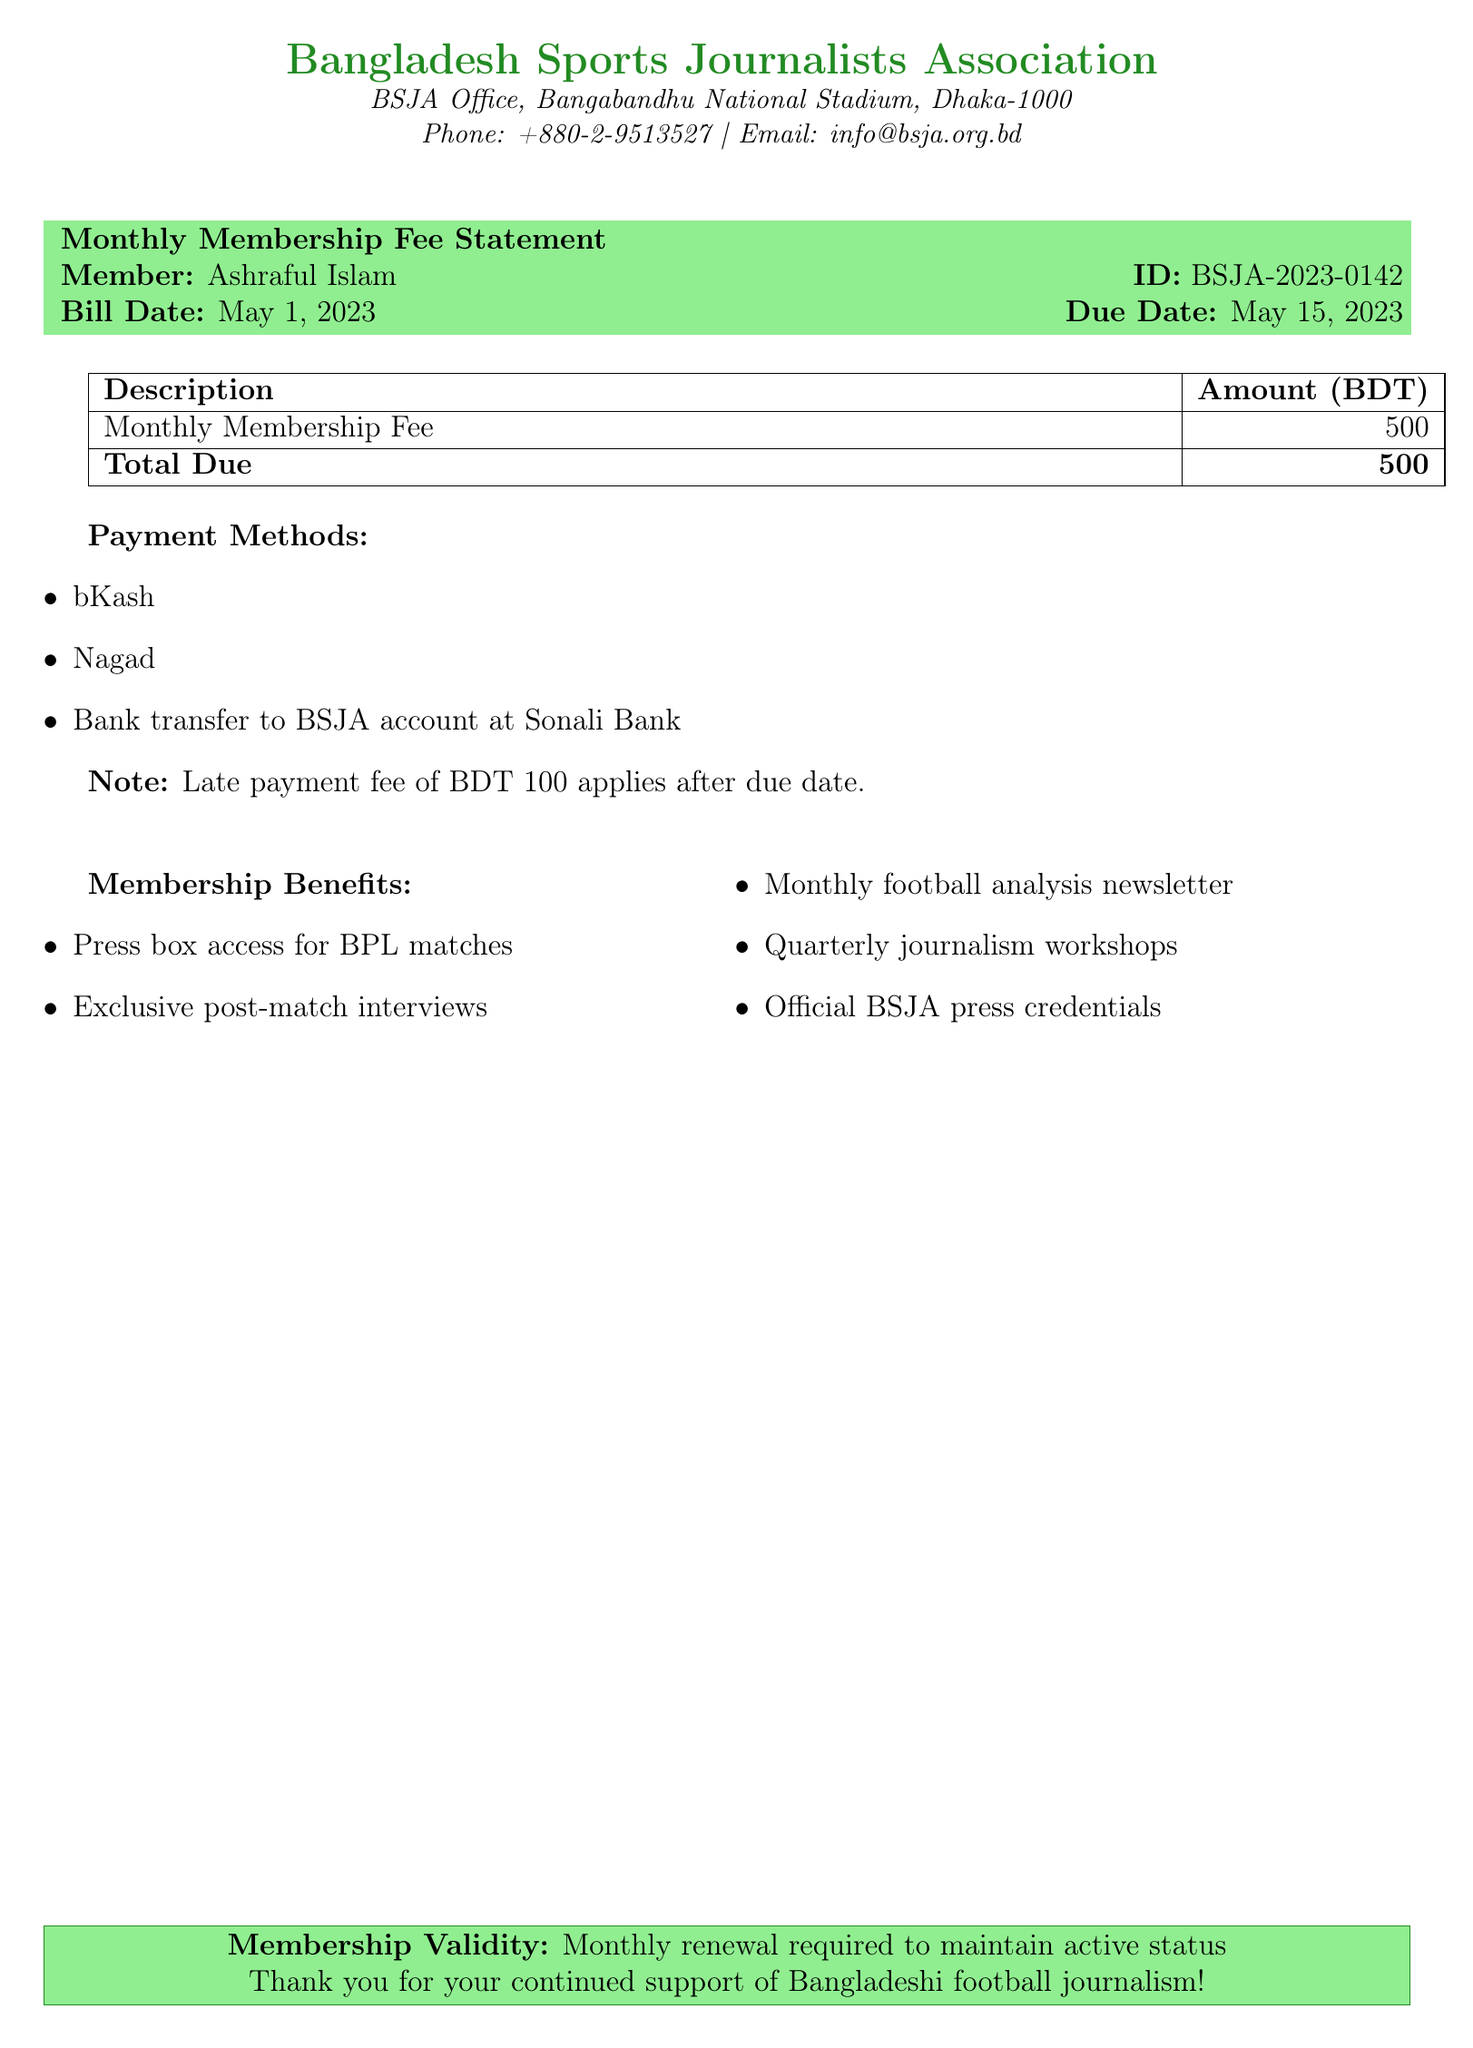what is the total due amount? The total due amount is specified in the bill as the total fee required from the member.
Answer: 500 who is the member mentioned in the statement? The member's name is noted in the document, identifying the individual associated with the membership fee.
Answer: Ashraful Islam what is the membership validity duration? The document states the requirement for renewal, indicating how long the membership remains active before needing renewal.
Answer: Monthly what is the late payment fee? The document mentions a fee that applies if the payment is not made by the due date.
Answer: 100 when is the bill date? The bill date indicates when the membership fee statement was created and is clearly specified in the document.
Answer: May 1, 2023 what are the payment methods listed? The document outlines various methods available for making the membership fee payment, showcasing the options provided to members.
Answer: bKash, Nagad, Bank transfer to BSJA account at Sonali Bank what benefits do members receive? The document highlights specific privileges and services that come with the membership, emphasizing the advantages for members.
Answer: Press box access for BPL matches, Exclusive post-match interviews, Monthly football analysis newsletter, Quarterly journalism workshops, Official BSJA press credentials what is the ID of the member? The member ID is included in the statement, serving as a unique identifier for the individual within the association.
Answer: BSJA-2023-0142 